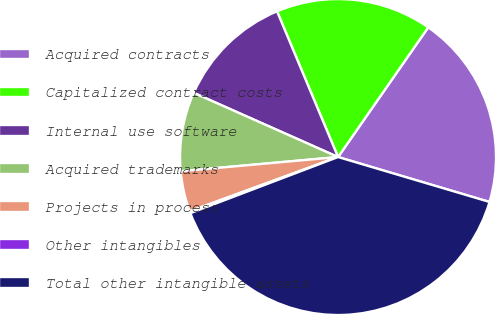Convert chart. <chart><loc_0><loc_0><loc_500><loc_500><pie_chart><fcel>Acquired contracts<fcel>Capitalized contract costs<fcel>Internal use software<fcel>Acquired trademarks<fcel>Projects in process<fcel>Other intangibles<fcel>Total other intangible assets<nl><fcel>19.92%<fcel>15.98%<fcel>12.03%<fcel>8.09%<fcel>4.15%<fcel>0.2%<fcel>39.63%<nl></chart> 